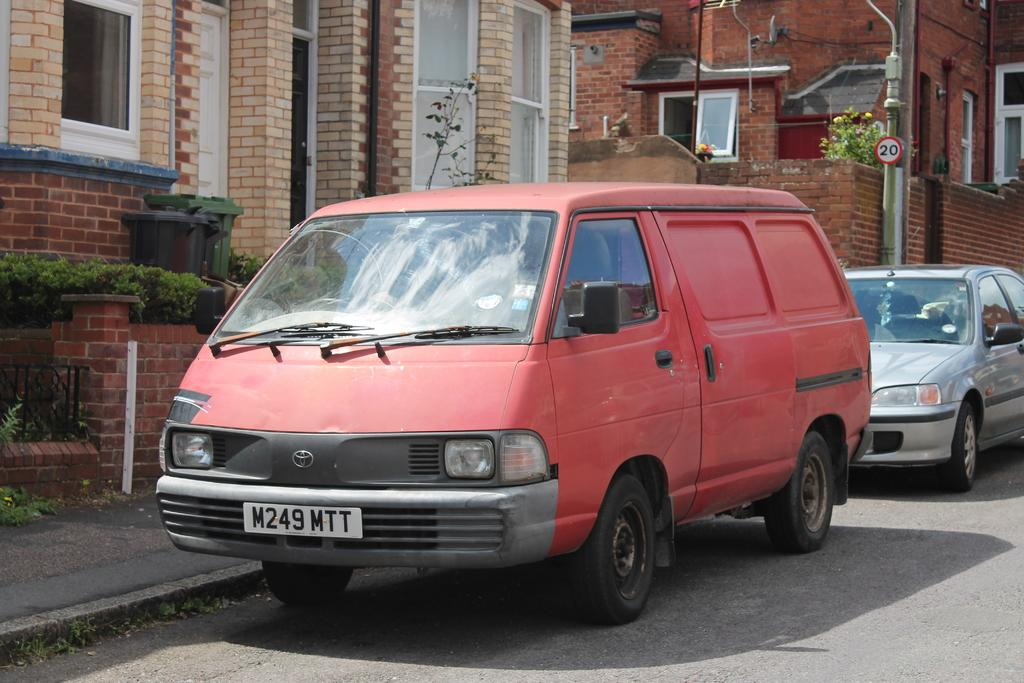<image>
Summarize the visual content of the image. A red van is parked on the side of the road. 